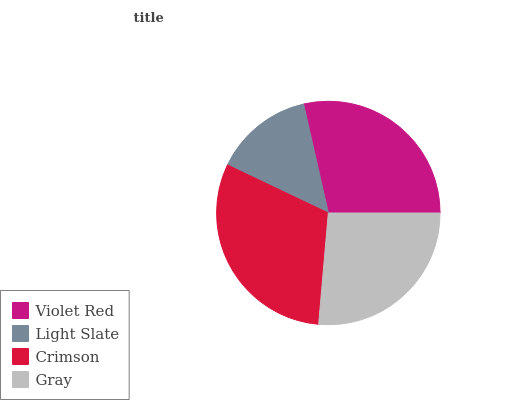Is Light Slate the minimum?
Answer yes or no. Yes. Is Crimson the maximum?
Answer yes or no. Yes. Is Crimson the minimum?
Answer yes or no. No. Is Light Slate the maximum?
Answer yes or no. No. Is Crimson greater than Light Slate?
Answer yes or no. Yes. Is Light Slate less than Crimson?
Answer yes or no. Yes. Is Light Slate greater than Crimson?
Answer yes or no. No. Is Crimson less than Light Slate?
Answer yes or no. No. Is Violet Red the high median?
Answer yes or no. Yes. Is Gray the low median?
Answer yes or no. Yes. Is Gray the high median?
Answer yes or no. No. Is Crimson the low median?
Answer yes or no. No. 